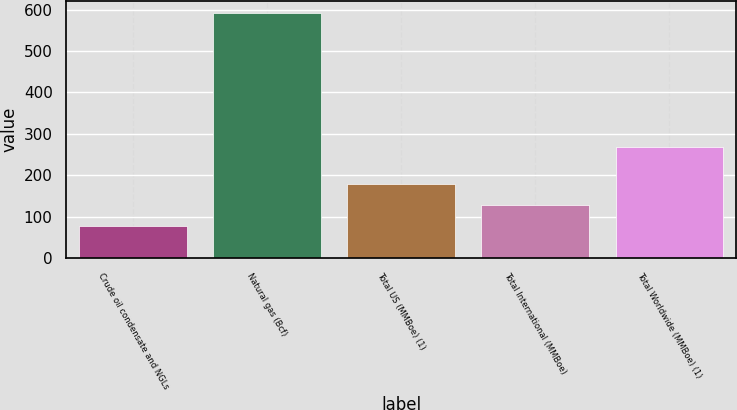Convert chart to OTSL. <chart><loc_0><loc_0><loc_500><loc_500><bar_chart><fcel>Crude oil condensate and NGLs<fcel>Natural gas (Bcf)<fcel>Total US (MMBoe) (1)<fcel>Total International (MMBoe)<fcel>Total Worldwide (MMBoe) (1)<nl><fcel>77<fcel>591<fcel>179.8<fcel>128.4<fcel>268<nl></chart> 